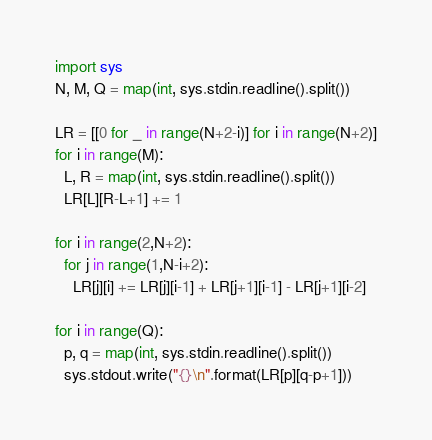<code> <loc_0><loc_0><loc_500><loc_500><_Python_>import sys
N, M, Q = map(int, sys.stdin.readline().split())
 
LR = [[0 for _ in range(N+2-i)] for i in range(N+2)]
for i in range(M):
  L, R = map(int, sys.stdin.readline().split())
  LR[L][R-L+1] += 1
 
for i in range(2,N+2):
  for j in range(1,N-i+2):
    LR[j][i] += LR[j][i-1] + LR[j+1][i-1] - LR[j+1][i-2]
 
for i in range(Q):
  p, q = map(int, sys.stdin.readline().split())
  sys.stdout.write("{}\n".format(LR[p][q-p+1]))</code> 